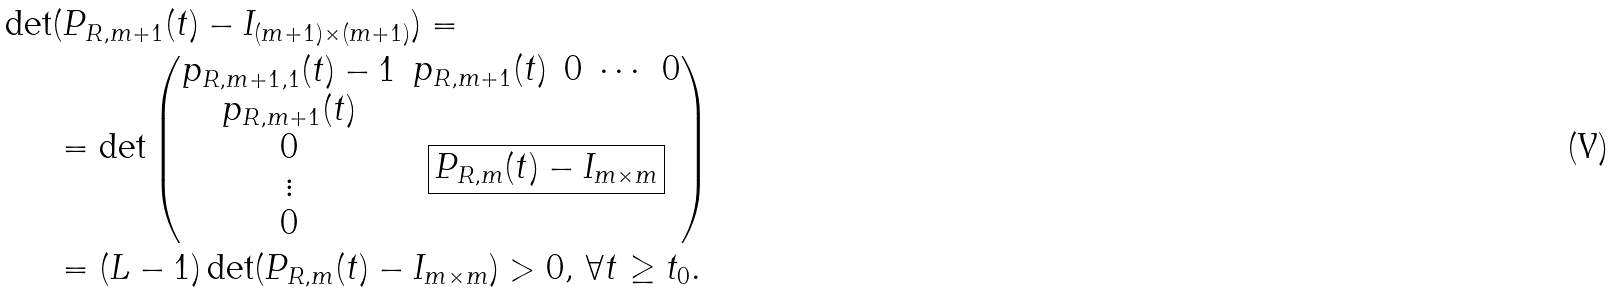Convert formula to latex. <formula><loc_0><loc_0><loc_500><loc_500>\det & ( P _ { R , m + 1 } ( t ) - I _ { ( m + 1 ) \times ( m + 1 ) } ) = \\ & = \det \left ( \begin{matrix} p _ { R , m + 1 , 1 } ( t ) - 1 & \begin{matrix} p _ { R , m + 1 } ( t ) & 0 & \cdots & 0 \end{matrix} \\ \begin{matrix} p _ { R , m + 1 } ( t ) \\ 0 \\ \vdots \\ 0 \end{matrix} & \boxed { P _ { R , m } ( t ) - I _ { m \times m } } \end{matrix} \right ) \\ & = ( L - 1 ) \det ( P _ { R , m } ( t ) - I _ { m \times m } ) > 0 , \, \forall t \geq t _ { 0 } .</formula> 